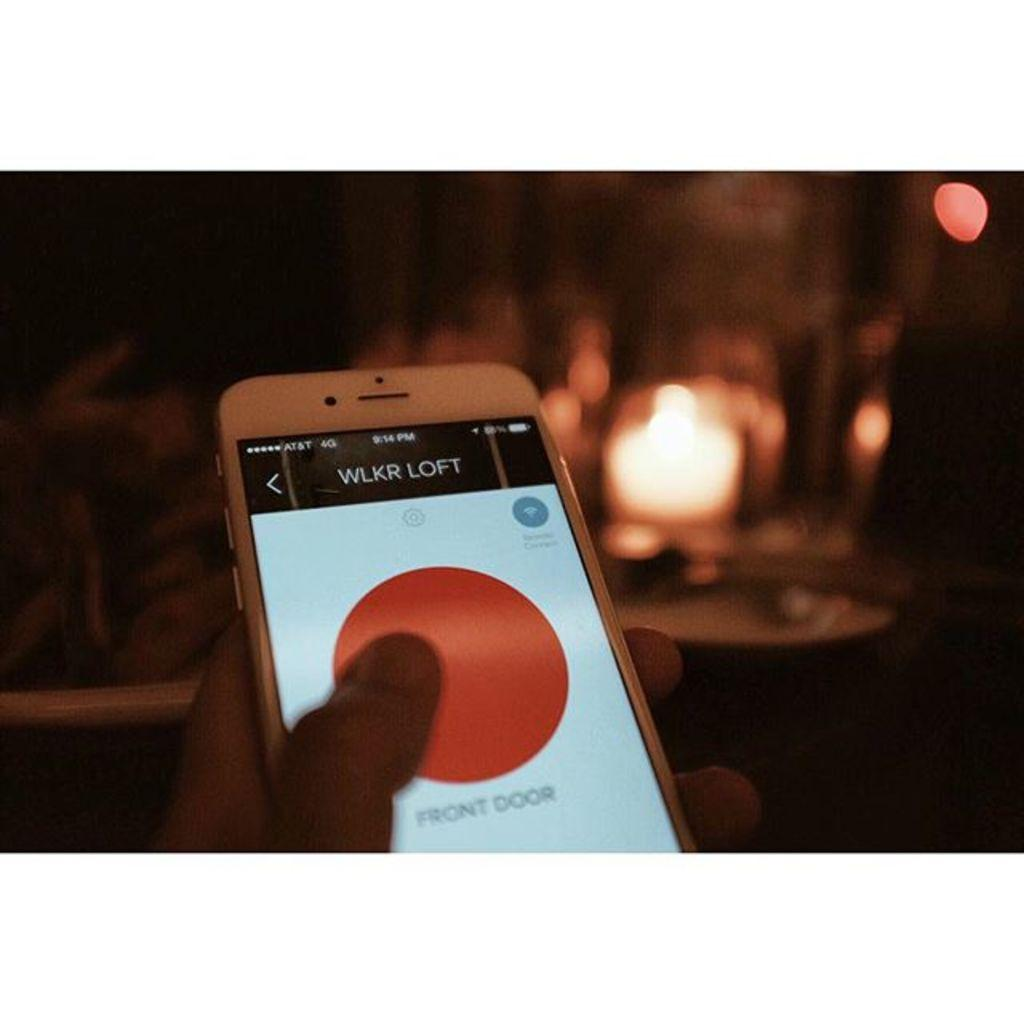<image>
Write a terse but informative summary of the picture. wlkr loft front door access button on a cellphone 